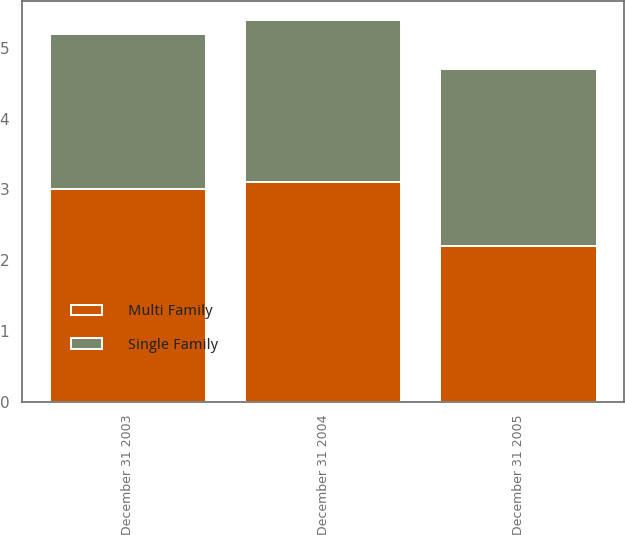Convert chart. <chart><loc_0><loc_0><loc_500><loc_500><stacked_bar_chart><ecel><fcel>December 31 2005<fcel>December 31 2004<fcel>December 31 2003<nl><fcel>Single Family<fcel>2.5<fcel>2.3<fcel>2.2<nl><fcel>Multi Family<fcel>2.2<fcel>3.1<fcel>3<nl></chart> 